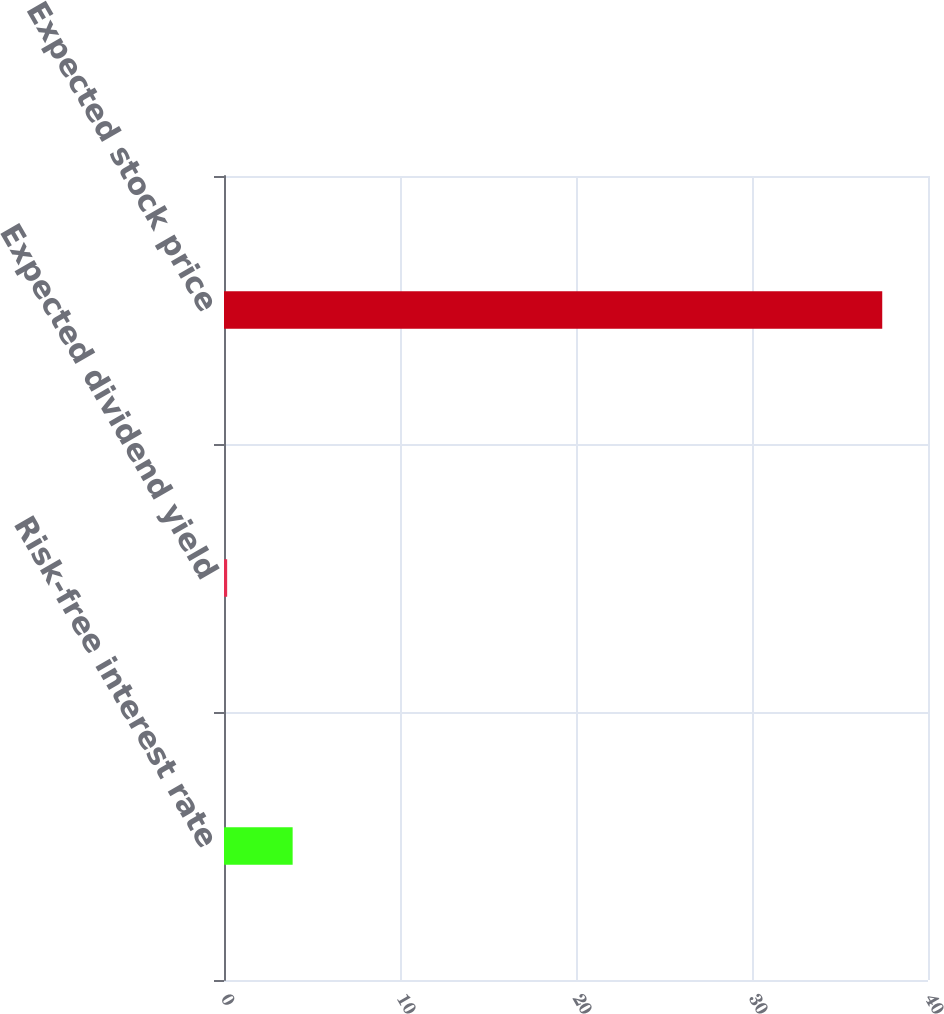Convert chart. <chart><loc_0><loc_0><loc_500><loc_500><bar_chart><fcel>Risk-free interest rate<fcel>Expected dividend yield<fcel>Expected stock price<nl><fcel>3.9<fcel>0.18<fcel>37.4<nl></chart> 